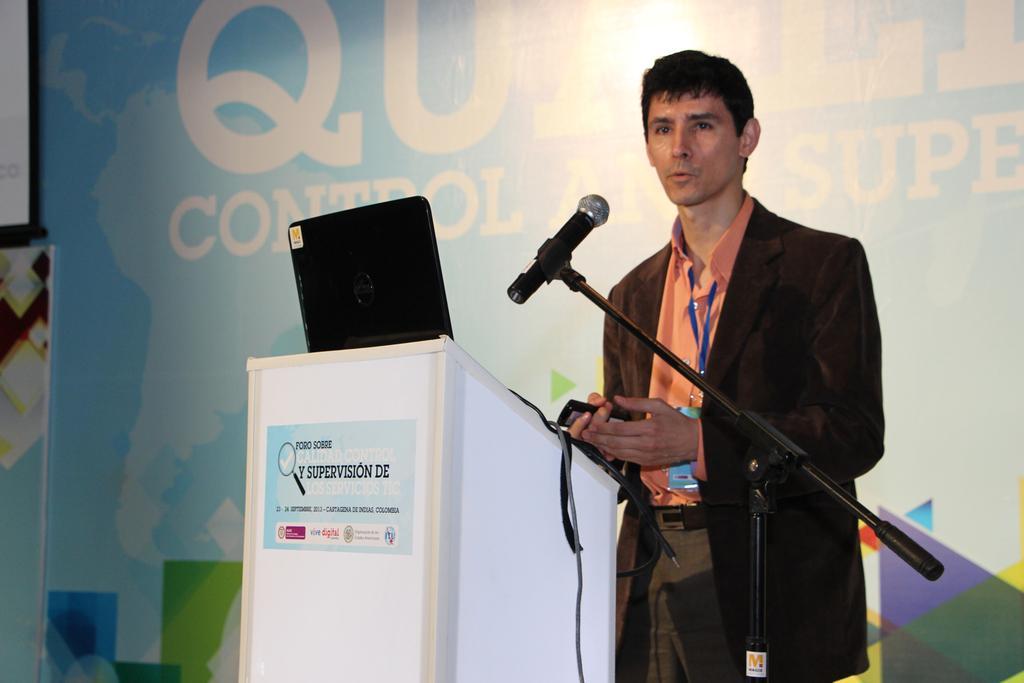Describe this image in one or two sentences. This image consists of a podium. There is a laptop on that. There is a person standing in the middle. There is a mic in front of him. 